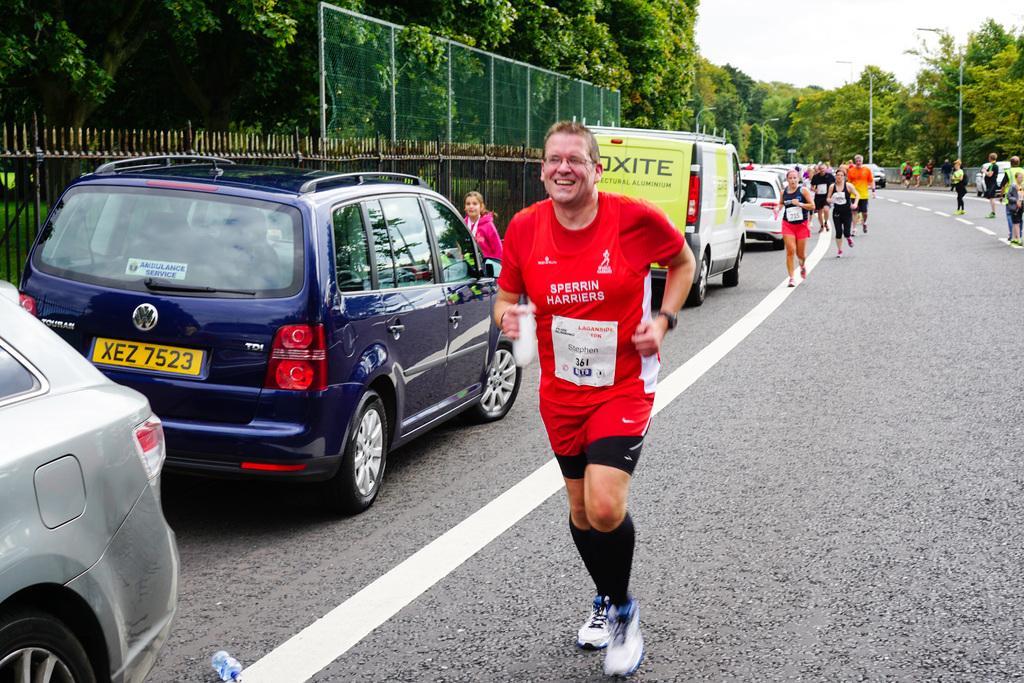Can you describe this image briefly? In this image we can see a few people running, a few people standing on the road and a few vehicles parked beside the road, there is a fence on the left side and in the background there are few trees, street light and sky. 